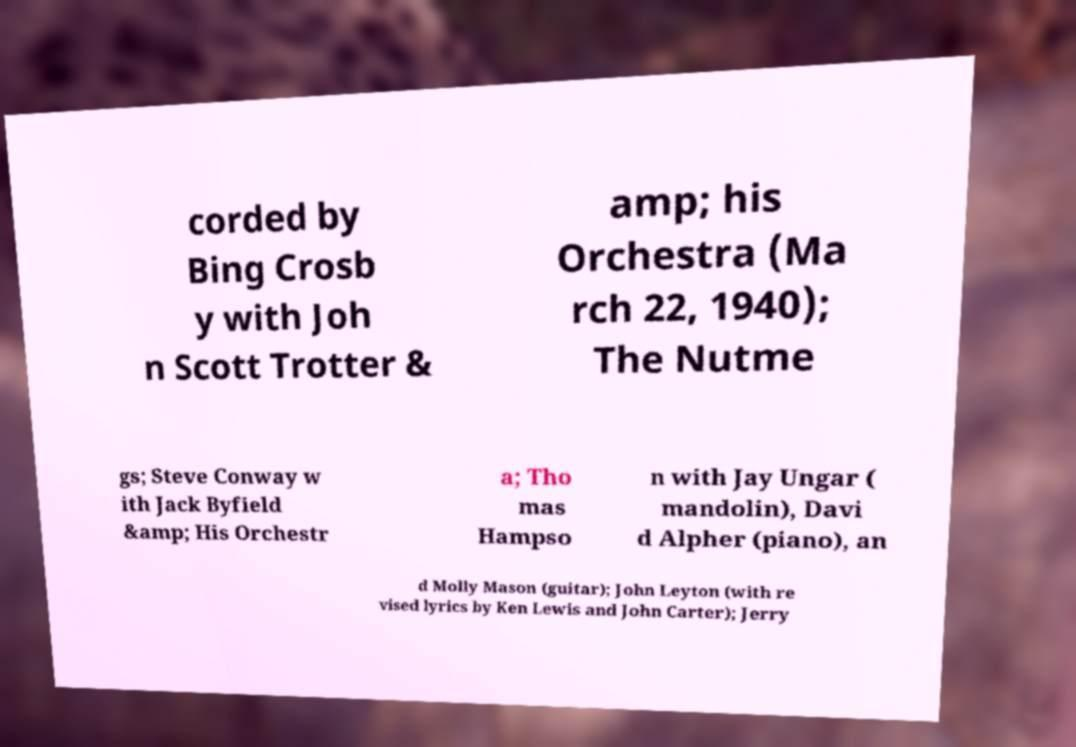Please identify and transcribe the text found in this image. corded by Bing Crosb y with Joh n Scott Trotter & amp; his Orchestra (Ma rch 22, 1940); The Nutme gs; Steve Conway w ith Jack Byfield &amp; His Orchestr a; Tho mas Hampso n with Jay Ungar ( mandolin), Davi d Alpher (piano), an d Molly Mason (guitar); John Leyton (with re vised lyrics by Ken Lewis and John Carter); Jerry 